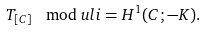Convert formula to latex. <formula><loc_0><loc_0><loc_500><loc_500>T _ { [ C ] } \mod u l i = H ^ { 1 } ( C ; - K ) .</formula> 